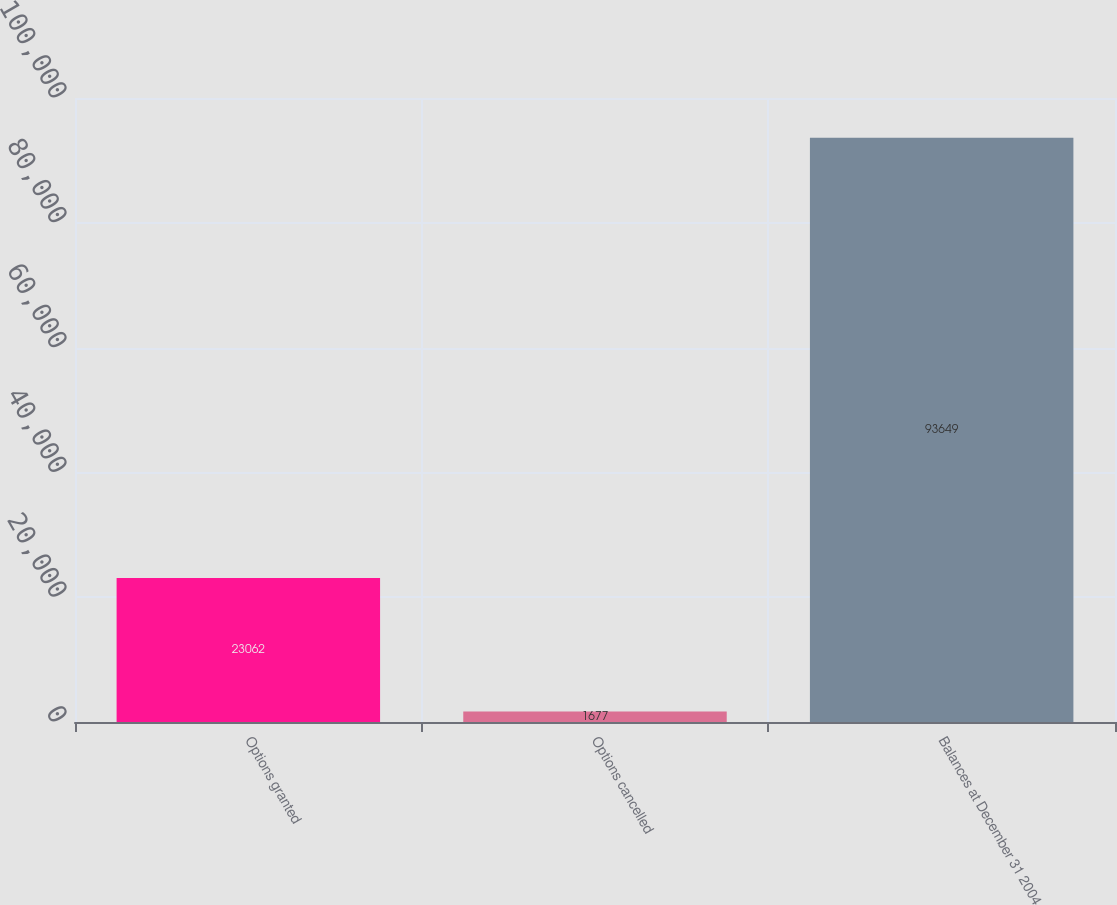<chart> <loc_0><loc_0><loc_500><loc_500><bar_chart><fcel>Options granted<fcel>Options cancelled<fcel>Balances at December 31 2004<nl><fcel>23062<fcel>1677<fcel>93649<nl></chart> 